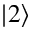Convert formula to latex. <formula><loc_0><loc_0><loc_500><loc_500>| 2 \rangle</formula> 